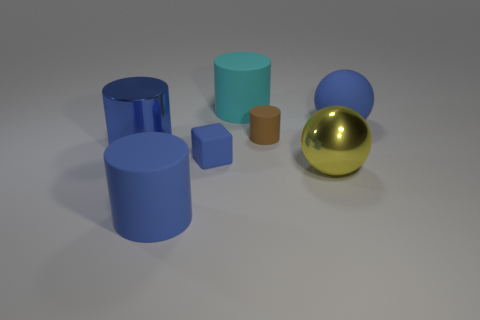There is a cyan cylinder that is the same size as the yellow metal sphere; what is it made of?
Your answer should be very brief. Rubber. Are there fewer big cyan rubber things behind the big cyan object than tiny blocks?
Make the answer very short. Yes. What shape is the big shiny object on the right side of the cylinder that is behind the small thing right of the tiny blue rubber thing?
Keep it short and to the point. Sphere. There is a blue thing behind the metallic cylinder; how big is it?
Ensure brevity in your answer.  Large. What is the shape of the cyan rubber thing that is the same size as the blue ball?
Your response must be concise. Cylinder. How many things are either blue metallic spheres or big rubber cylinders that are to the left of the cyan rubber object?
Make the answer very short. 1. There is a large blue matte object that is on the left side of the large blue object that is to the right of the small blue cube; what number of blue objects are to the left of it?
Give a very brief answer. 1. What is the color of the other large object that is the same material as the big yellow object?
Give a very brief answer. Blue. Does the rubber cylinder that is in front of the blue metal cylinder have the same size as the blue sphere?
Make the answer very short. Yes. What number of things are either tiny blue cubes or large brown metal blocks?
Make the answer very short. 1. 